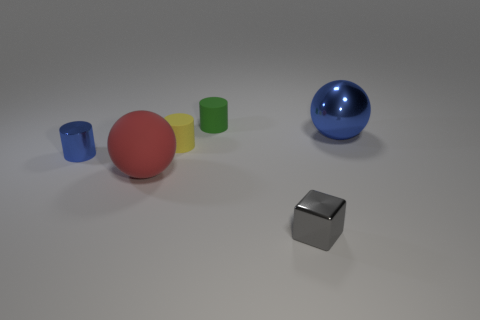Add 1 small matte objects. How many objects exist? 7 Subtract all cubes. How many objects are left? 5 Add 5 gray objects. How many gray objects are left? 6 Add 6 yellow matte objects. How many yellow matte objects exist? 7 Subtract 0 brown balls. How many objects are left? 6 Subtract all large blue objects. Subtract all yellow rubber cylinders. How many objects are left? 4 